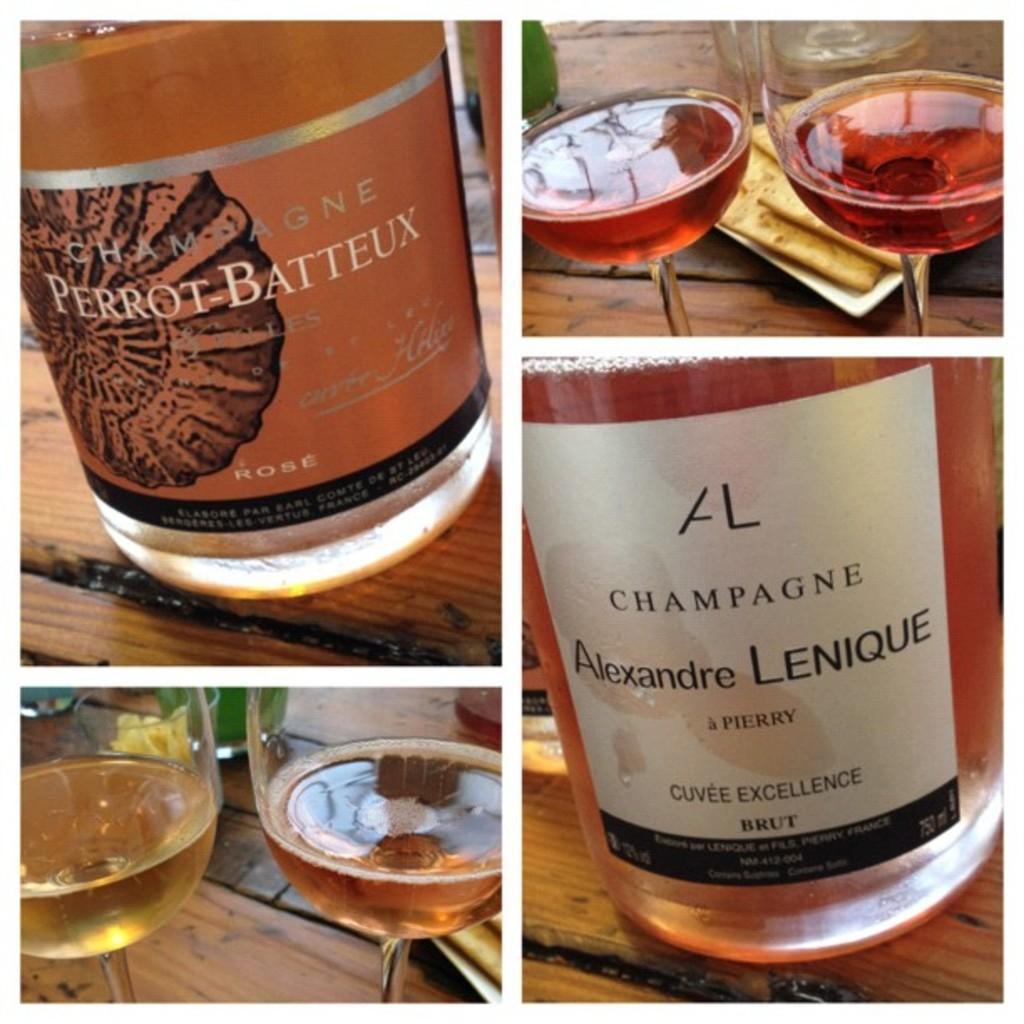<image>
Render a clear and concise summary of the photo. Glasses of champagne from the makers Perrot Batteaux and Alexandre Lenique. 